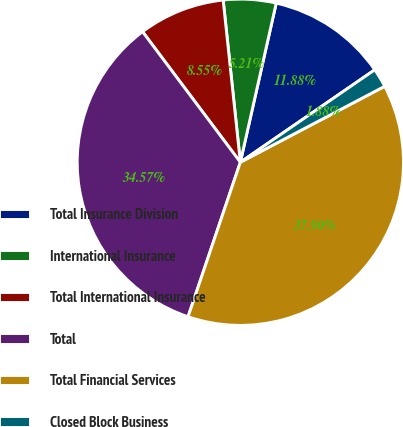Convert chart. <chart><loc_0><loc_0><loc_500><loc_500><pie_chart><fcel>Total Insurance Division<fcel>International Insurance<fcel>Total International Insurance<fcel>Total<fcel>Total Financial Services<fcel>Closed Block Business<nl><fcel>11.88%<fcel>5.21%<fcel>8.55%<fcel>34.57%<fcel>37.9%<fcel>1.88%<nl></chart> 